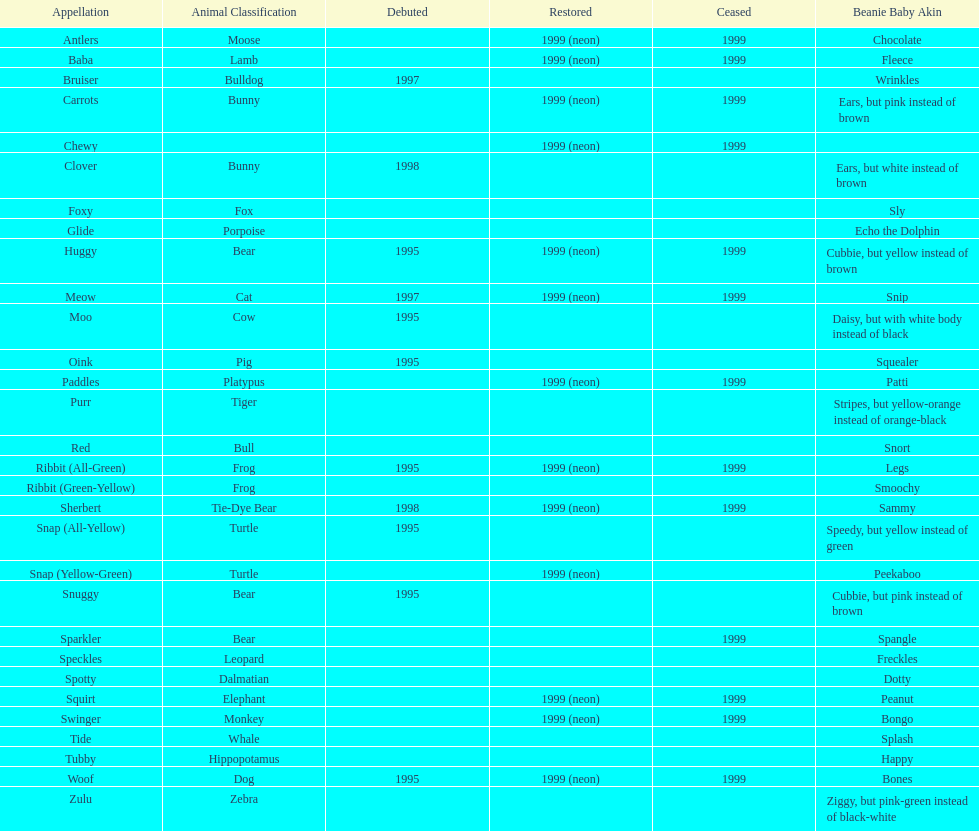What are the total number of pillow pals on this chart? 30. 